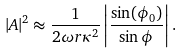<formula> <loc_0><loc_0><loc_500><loc_500>| A | ^ { 2 } \approx \frac { 1 } { 2 \omega r \kappa ^ { 2 } } \left | \frac { \sin ( \phi _ { 0 } ) } { \sin \phi } \right | .</formula> 